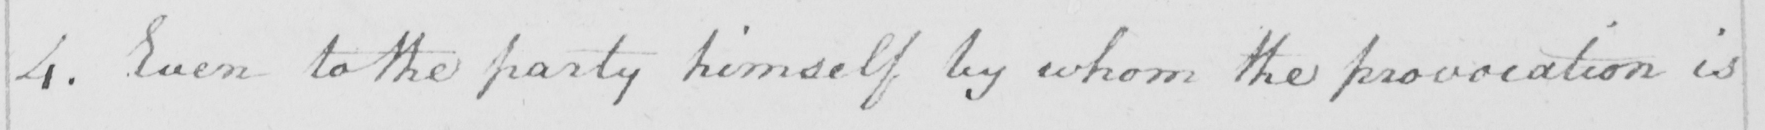Transcribe the text shown in this historical manuscript line. 4. Even to the party himself by whom the provocation is 